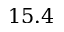Convert formula to latex. <formula><loc_0><loc_0><loc_500><loc_500>1 5 . 4</formula> 